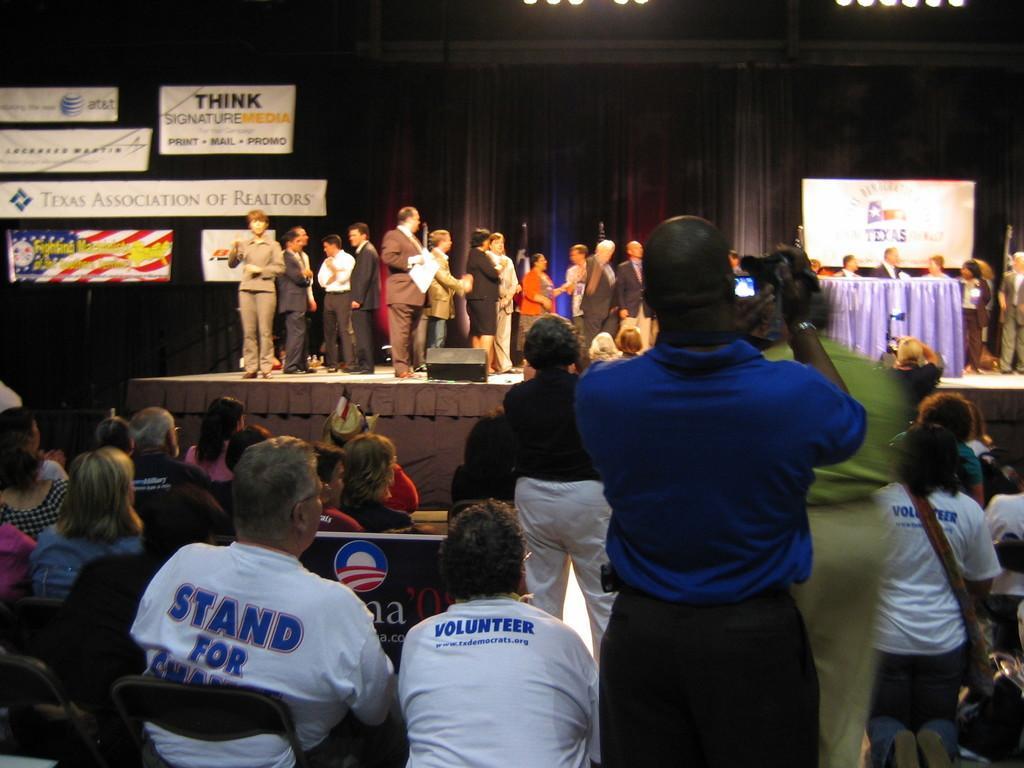Could you give a brief overview of what you see in this image? In this picture there are group of people standing on the stage and there is a table covered with purple color cloth and there are hoardings and there are curtains. In the foreground there are group of people sitting on the chairs and there is a person with blue t-shirt is standing and holding the camera. At the top there are lights. 